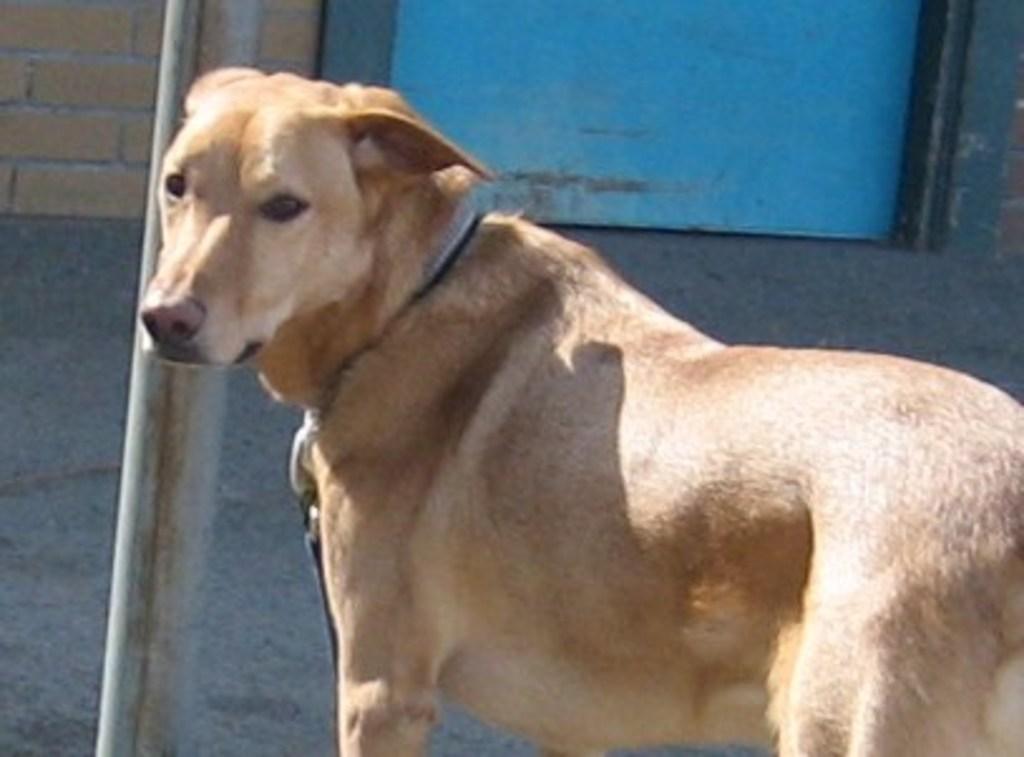How would you summarize this image in a sentence or two? In this image I can see a dog which is brown, cream and black in color. I can see a belt to its neck, a metal pole, the ground, a blue colored door and the wall which is made up of bricks. 